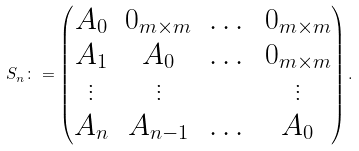<formula> <loc_0><loc_0><loc_500><loc_500>S _ { n } \colon = \begin{pmatrix} A _ { 0 } & 0 _ { m \times m } & \dots & 0 _ { m \times m } \\ A _ { 1 } & A _ { 0 } & \dots & 0 _ { m \times m } \\ \vdots & \vdots & & \vdots \\ A _ { n } & A _ { n - 1 } & \dots & A _ { 0 } \end{pmatrix} .</formula> 